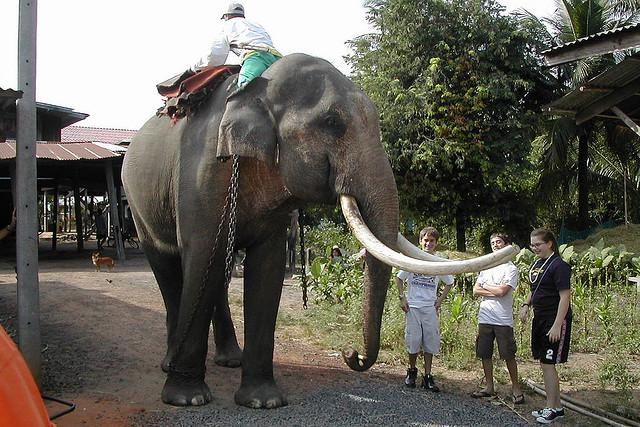Why is it unusual for elephants to have tusks this big? Please explain your reasoning. attracts poachers. Most tusks on elephants are a bit shorter than the one presented here. 